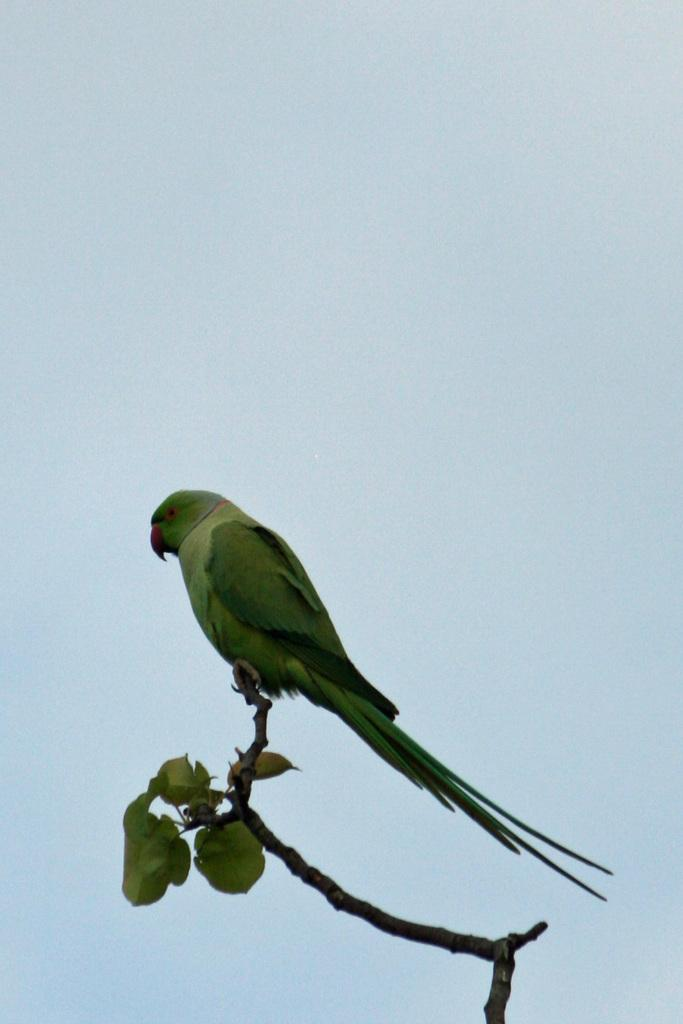What type of animal can be seen in the image? There is a bird in the image. Where is the bird located? The bird is on the branch of a plant. What can be seen in the background of the image? The sky is visible in the image. What type of bed can be seen in the image? There is no bed present in the image; it features a bird on the branch of a plant with the sky visible in the background. Is there a fireman in the image? There is no fireman present in the image. 